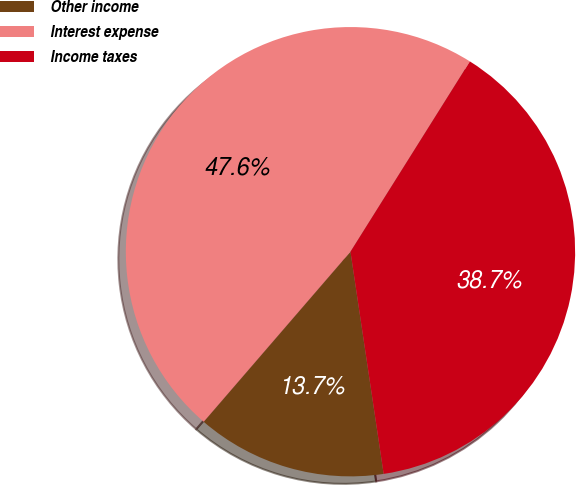Convert chart to OTSL. <chart><loc_0><loc_0><loc_500><loc_500><pie_chart><fcel>Other income<fcel>Interest expense<fcel>Income taxes<nl><fcel>13.69%<fcel>47.59%<fcel>38.72%<nl></chart> 